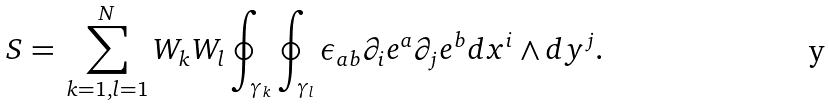Convert formula to latex. <formula><loc_0><loc_0><loc_500><loc_500>S = \, \sum _ { k = 1 , l = 1 } ^ { N } W _ { k } W _ { l } \oint _ { \gamma _ { k } } \oint _ { \gamma _ { l } } \epsilon _ { a b } \partial _ { i } e ^ { a } \partial _ { j } e ^ { b } d x ^ { i } \wedge d y ^ { j } .</formula> 